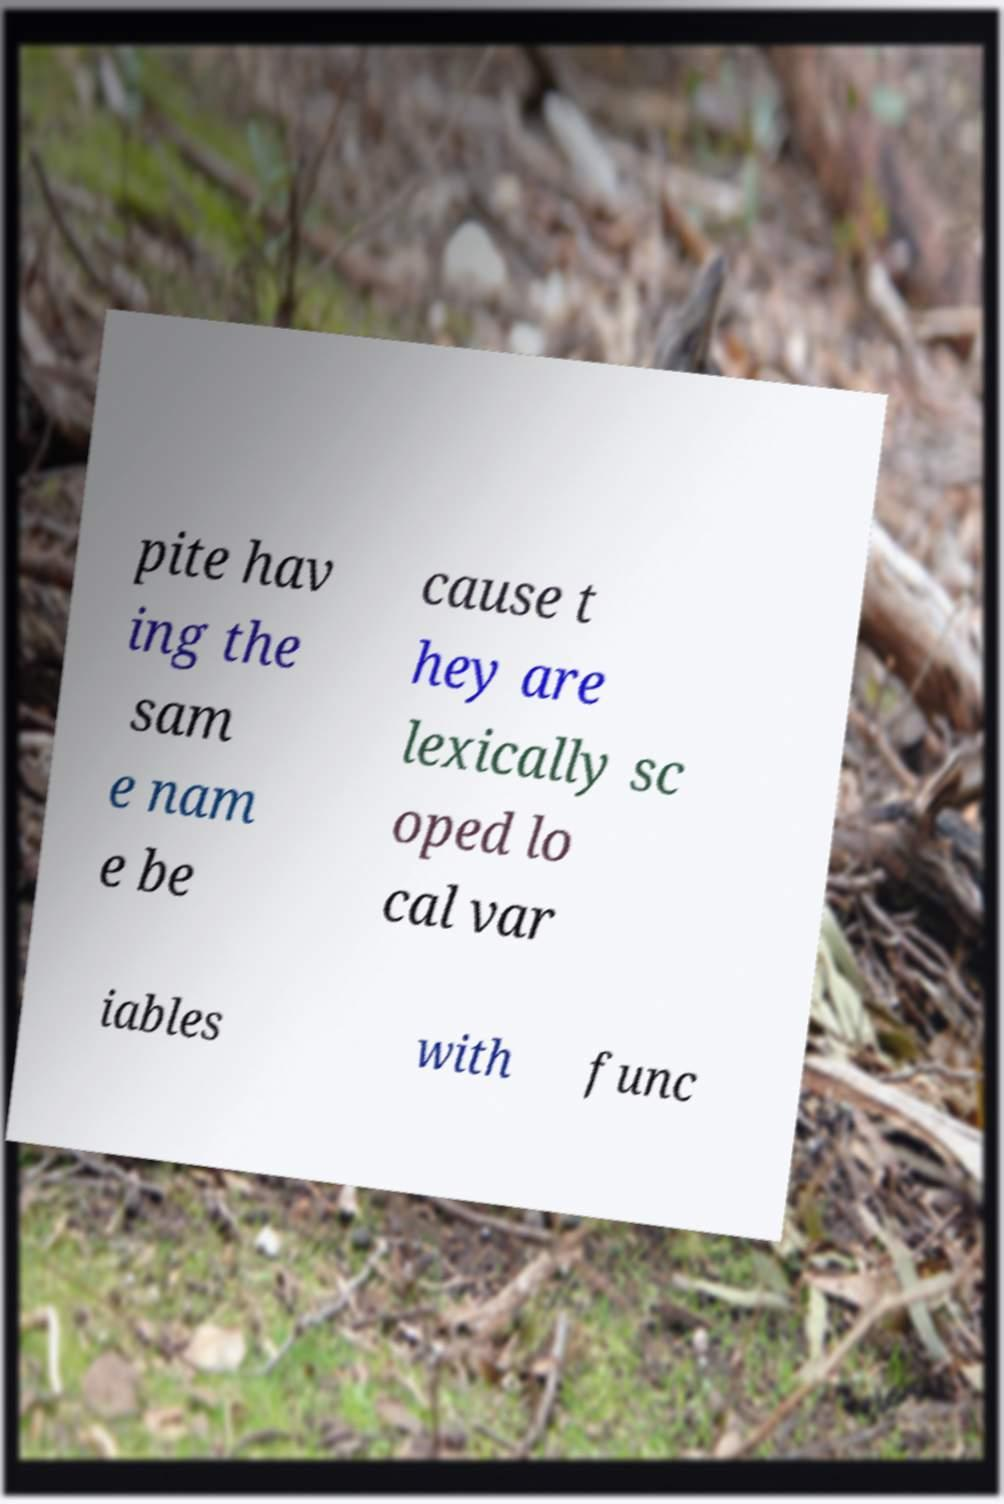Can you read and provide the text displayed in the image?This photo seems to have some interesting text. Can you extract and type it out for me? pite hav ing the sam e nam e be cause t hey are lexically sc oped lo cal var iables with func 